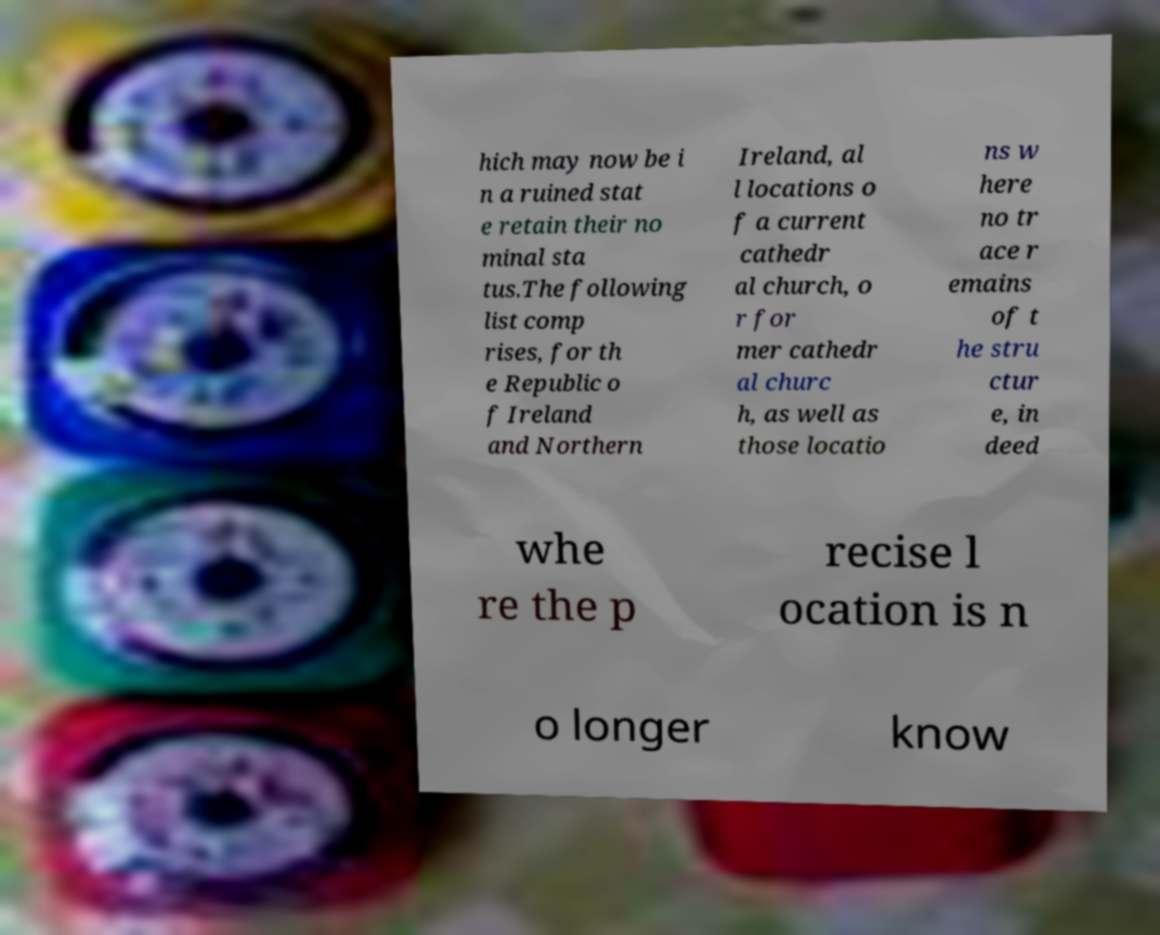Please identify and transcribe the text found in this image. hich may now be i n a ruined stat e retain their no minal sta tus.The following list comp rises, for th e Republic o f Ireland and Northern Ireland, al l locations o f a current cathedr al church, o r for mer cathedr al churc h, as well as those locatio ns w here no tr ace r emains of t he stru ctur e, in deed whe re the p recise l ocation is n o longer know 